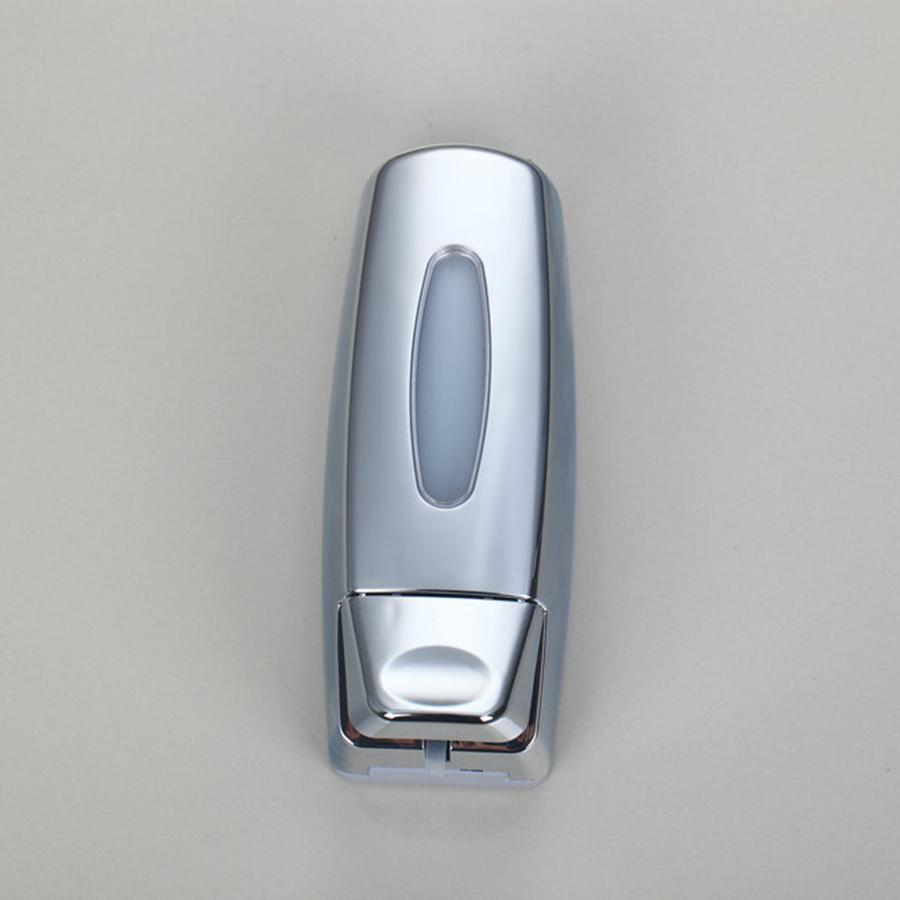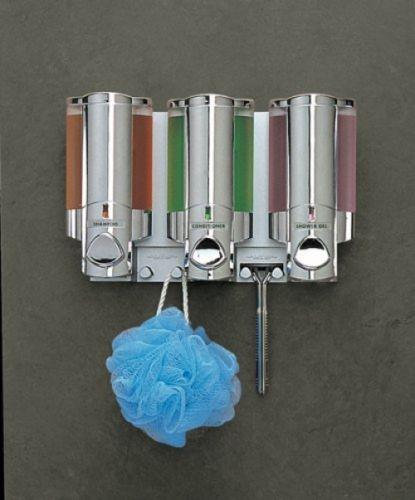The first image is the image on the left, the second image is the image on the right. Analyze the images presented: Is the assertion "A three-in-one joined dispenser holds substances of three different colors that show through the transparent top portions." valid? Answer yes or no. Yes. The first image is the image on the left, the second image is the image on the right. Considering the images on both sides, is "The right hand image shows three dispensers that each have a different color of liquid inside of them." valid? Answer yes or no. Yes. 